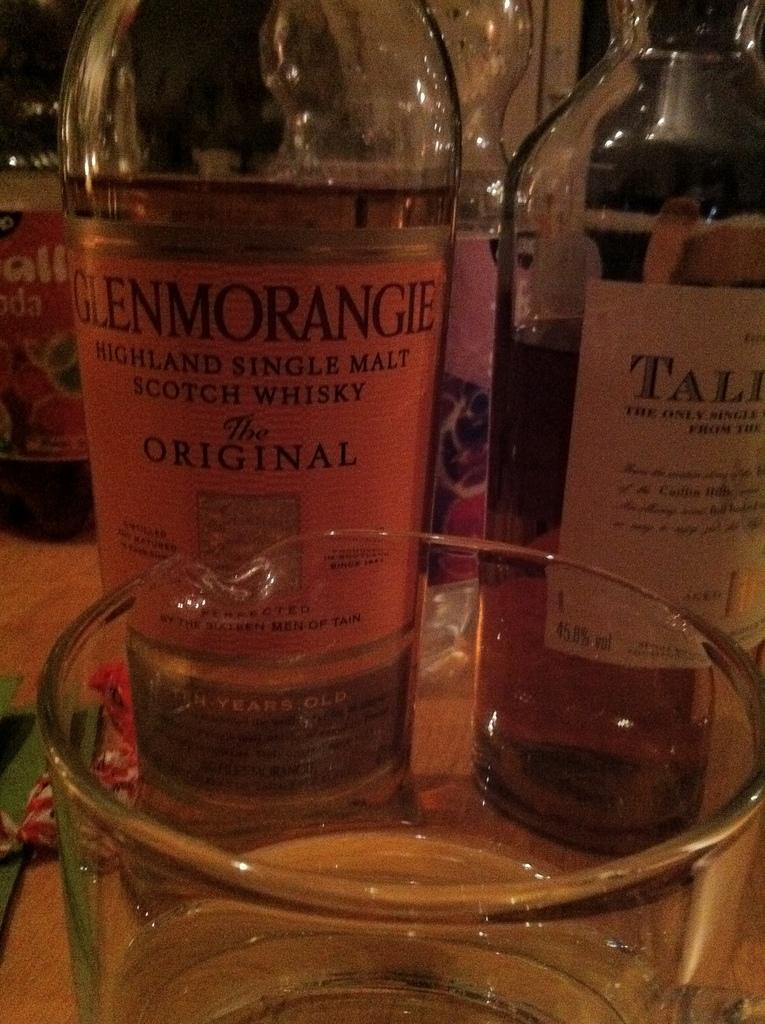<image>
Write a terse but informative summary of the picture. A bottle of Glenmorangie whiskey sits behind a glass. 